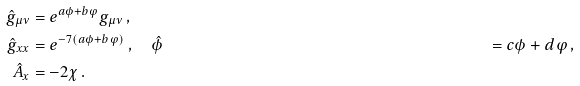Convert formula to latex. <formula><loc_0><loc_0><loc_500><loc_500>\hat { g } _ { \mu \nu } & = e ^ { a \phi + b \varphi } g _ { \mu \nu } \, , \\ \hat { g } _ { x x } & = e ^ { - 7 ( a \phi + b \varphi ) } \, , \quad \hat { \phi } & = c \phi + d \varphi \, , \\ \hat { A } _ { x } & = - 2 \chi \, .</formula> 